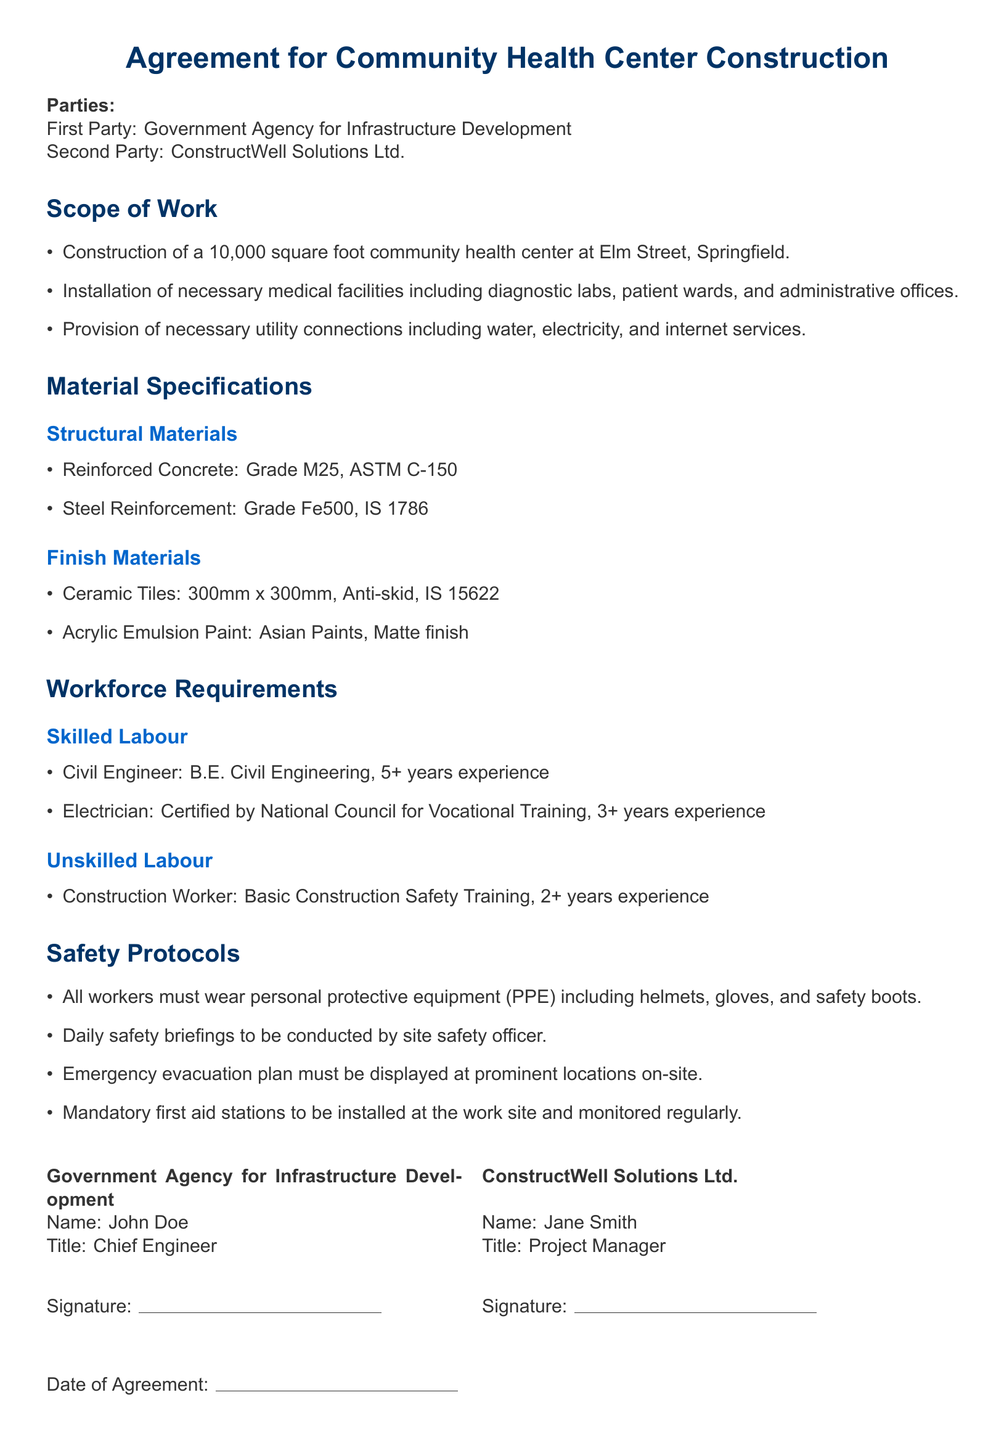What is the total area of the community health center? The document specifies that the construction area for the community health center is 10,000 square feet.
Answer: 10,000 square feet Who is the project manager for this construction? The document lists Jane Smith as the Project Manager for ConstructWell Solutions Ltd.
Answer: Jane Smith What grade is the reinforced concrete? The material specifications indicate that the reinforced concrete is Grade M25.
Answer: Grade M25 How many years of experience is required for the civil engineer? The workforce requirements state that a civil engineer must have 5+ years of experience.
Answer: 5+ years What safety equipment must all workers wear? The safety protocols mention that all workers must wear personal protective equipment including helmets, gloves, and safety boots.
Answer: helmets, gloves, and safety boots What type of paint is specified for the project? The document specifies that the paint to be used is Acrylic Emulsion Paint from Asian Paints with a matte finish.
Answer: Acrylic Emulsion Paint What is the required certification for the electrician? The text states that the electrician must be certified by the National Council for Vocational Training.
Answer: National Council for Vocational Training What is the date of the agreement? The date of the agreement is to be filled in by hand, as the document has a space for it but does not specify a date.
Answer: [To be filled] 